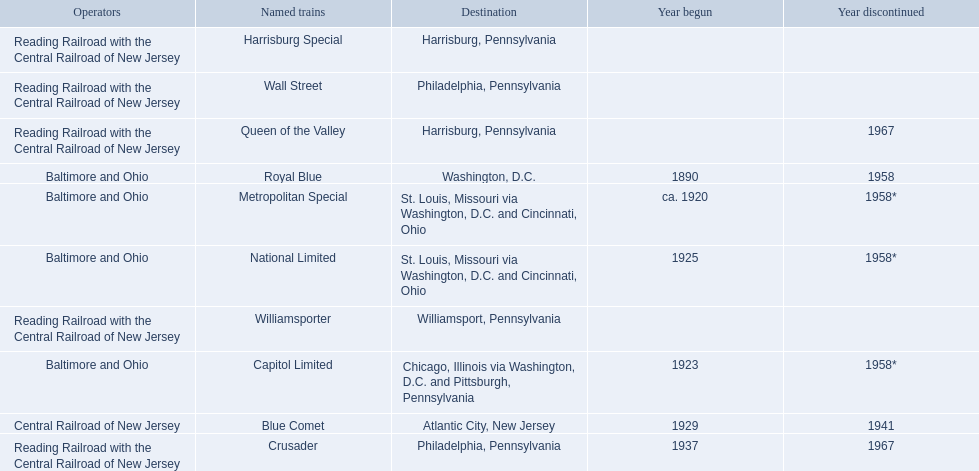What destinations are listed from the central railroad of new jersey terminal? Chicago, Illinois via Washington, D.C. and Pittsburgh, Pennsylvania, St. Louis, Missouri via Washington, D.C. and Cincinnati, Ohio, St. Louis, Missouri via Washington, D.C. and Cincinnati, Ohio, Washington, D.C., Atlantic City, New Jersey, Philadelphia, Pennsylvania, Harrisburg, Pennsylvania, Harrisburg, Pennsylvania, Philadelphia, Pennsylvania, Williamsport, Pennsylvania. Which of these destinations is listed first? Chicago, Illinois via Washington, D.C. and Pittsburgh, Pennsylvania. 